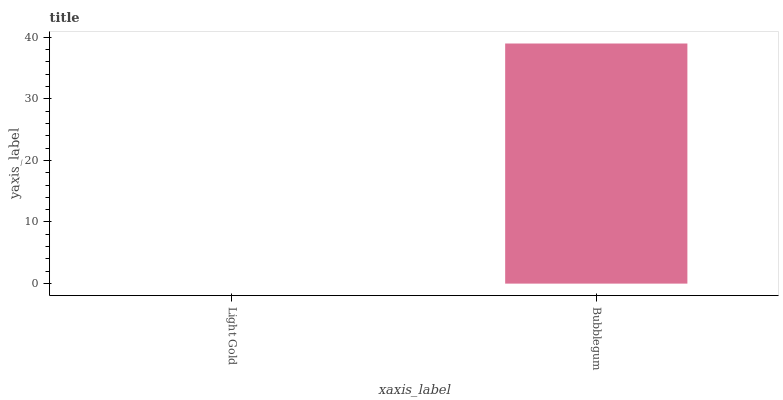Is Bubblegum the minimum?
Answer yes or no. No. Is Bubblegum greater than Light Gold?
Answer yes or no. Yes. Is Light Gold less than Bubblegum?
Answer yes or no. Yes. Is Light Gold greater than Bubblegum?
Answer yes or no. No. Is Bubblegum less than Light Gold?
Answer yes or no. No. Is Bubblegum the high median?
Answer yes or no. Yes. Is Light Gold the low median?
Answer yes or no. Yes. Is Light Gold the high median?
Answer yes or no. No. Is Bubblegum the low median?
Answer yes or no. No. 